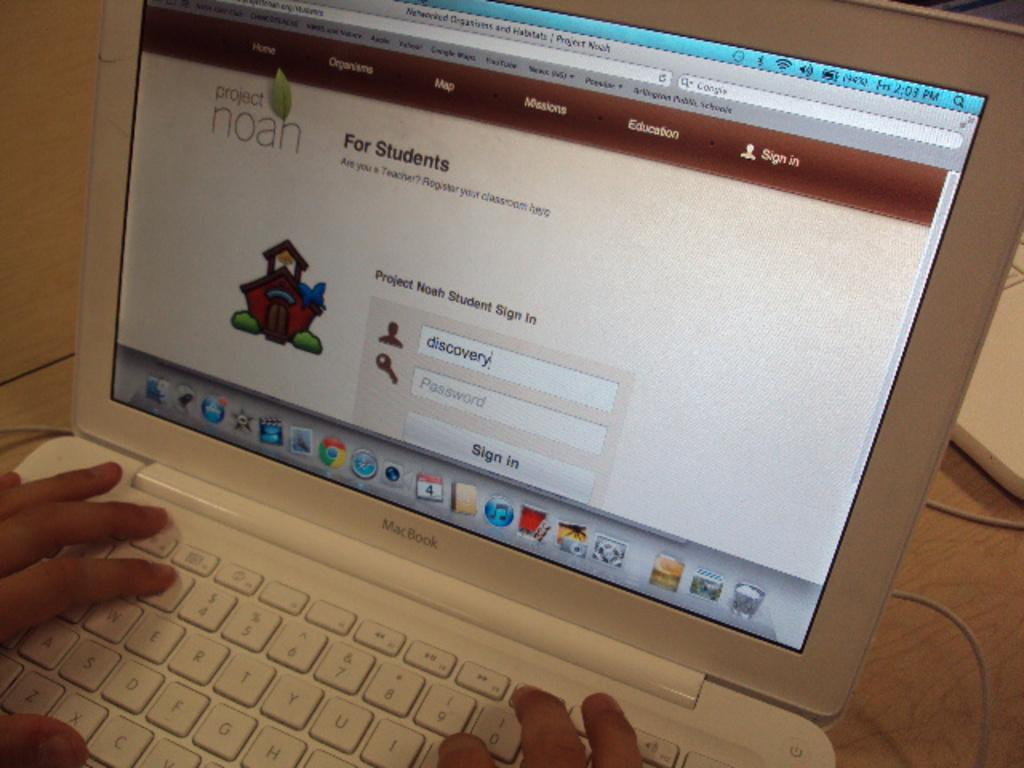<image>
Relay a brief, clear account of the picture shown. A white laptop computer that has the words, for students, on the screen. 